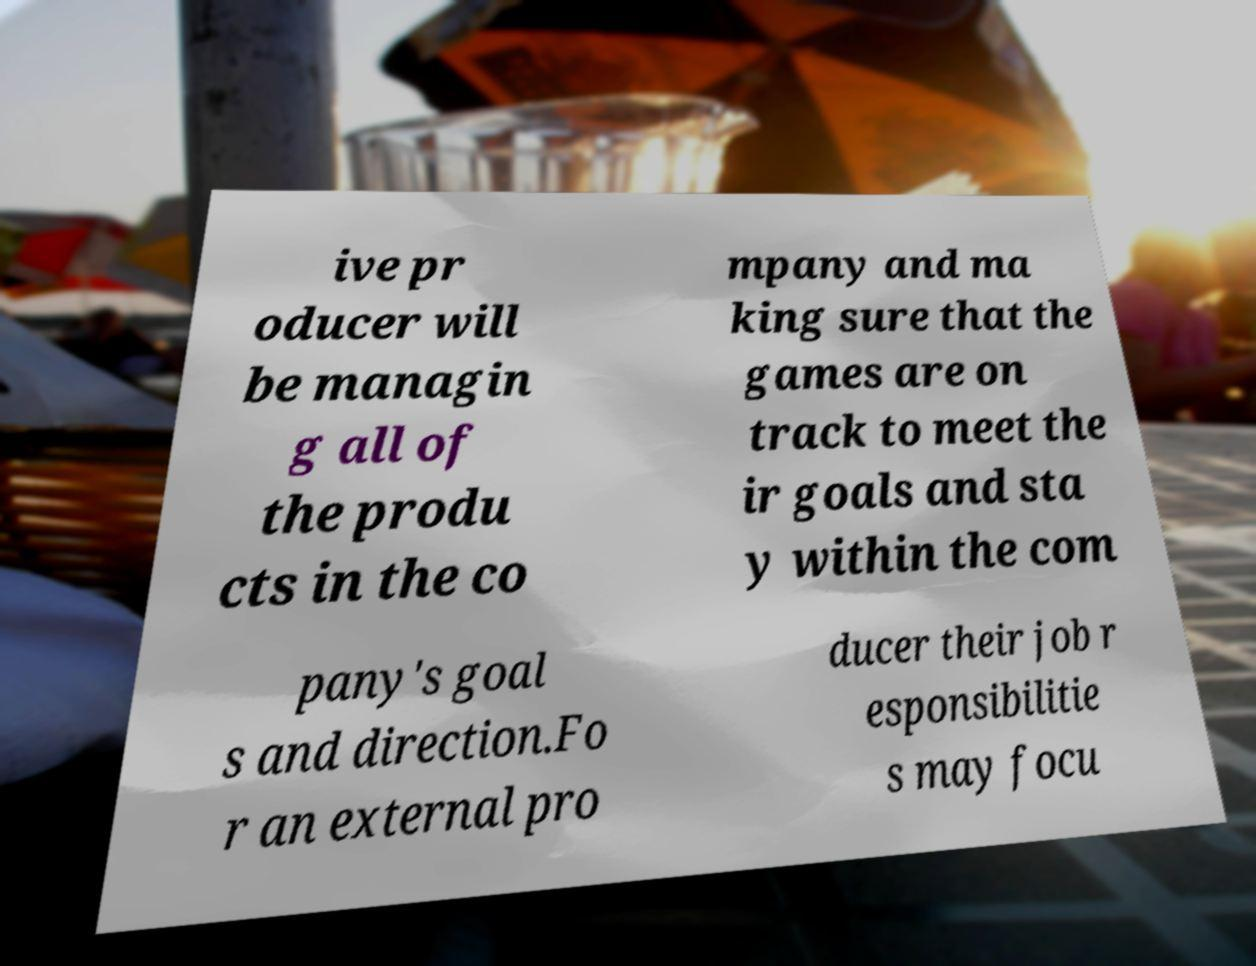Can you accurately transcribe the text from the provided image for me? ive pr oducer will be managin g all of the produ cts in the co mpany and ma king sure that the games are on track to meet the ir goals and sta y within the com pany's goal s and direction.Fo r an external pro ducer their job r esponsibilitie s may focu 